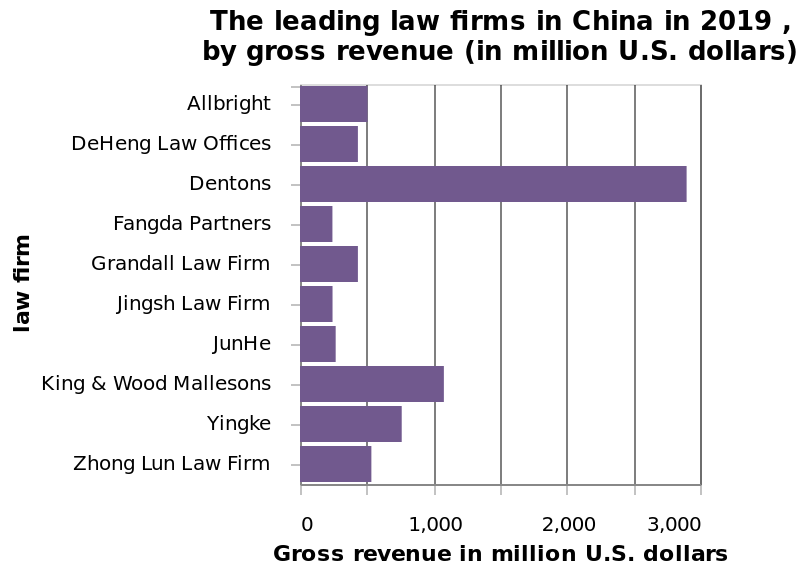<image>
How is gross revenue measured on the x-axis? Gross revenue is measured using a linear scale from 0 to 3,000 million U.S. dollars on the x-axis. please describe the details of the chart Here a is a bar chart titled The leading law firms in China in 2019 , by gross revenue (in million U.S. dollars). A categorical scale starting with Allbright and ending with  can be seen along the y-axis, marked law firm. Gross revenue in million U.S. dollars is measured using a linear scale from 0 to 3,000 on the x-axis. How many law firms made over €5000 million in revenue? Only 4 law firms made over €5000 million in revenue. Which law firm generated the second highest revenue in China?  King and Wood Malleson generated the second highest revenue in China. What is the title of the bar chart?  The leading law firms in China in 2019, by gross revenue (in million U.S. dollars). How much revenue did Denton law firm make compared to King and Wood Malleson? Denton law firm made over €2000 million more in revenue than King and Wood Malleson. 